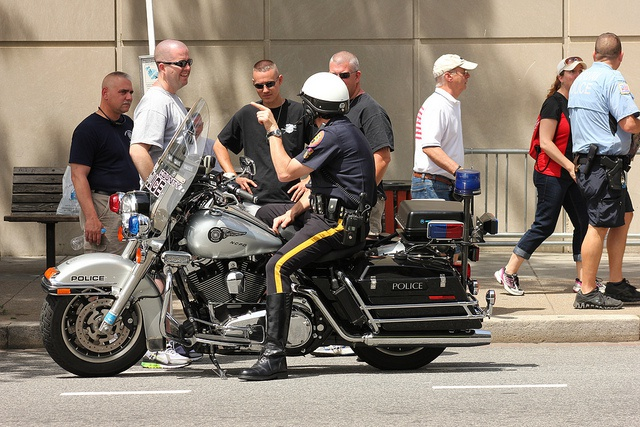Describe the objects in this image and their specific colors. I can see motorcycle in tan, black, darkgray, gray, and lightgray tones, people in tan, black, gray, and ivory tones, people in tan, black, lightgray, gray, and brown tones, people in tan, black, brown, gray, and maroon tones, and people in tan, black, and brown tones in this image. 